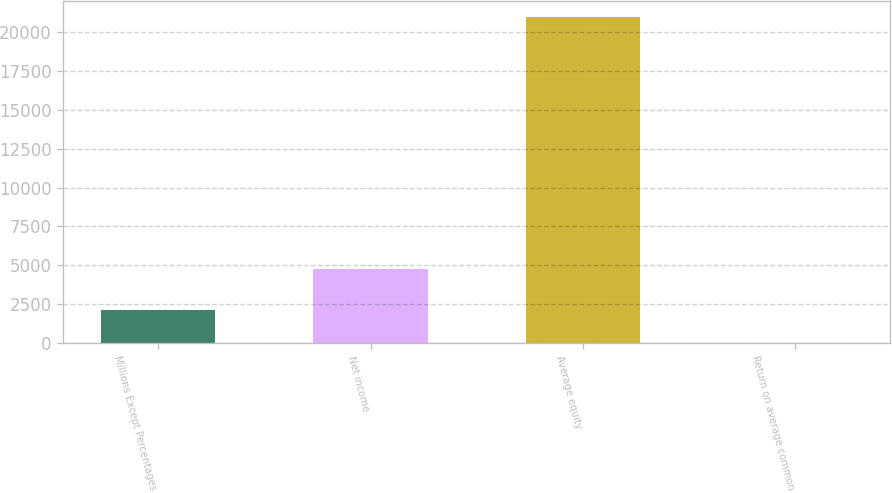Convert chart. <chart><loc_0><loc_0><loc_500><loc_500><bar_chart><fcel>Millions Except Percentages<fcel>Net income<fcel>Average equity<fcel>Return on average common<nl><fcel>2115.12<fcel>4772<fcel>20946<fcel>22.8<nl></chart> 